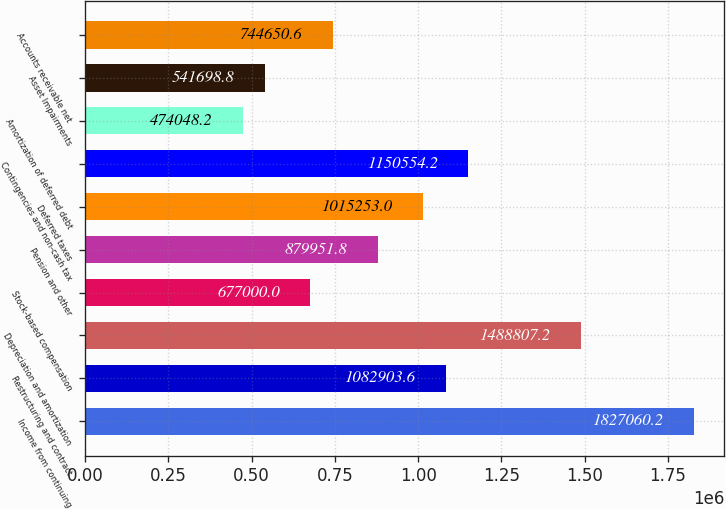Convert chart to OTSL. <chart><loc_0><loc_0><loc_500><loc_500><bar_chart><fcel>Income from continuing<fcel>Restructuring and contract<fcel>Depreciation and amortization<fcel>Stock-based compensation<fcel>Pension and other<fcel>Deferred taxes<fcel>Contingencies and non-cash tax<fcel>Amortization of deferred debt<fcel>Asset Impairments<fcel>Accounts receivable net<nl><fcel>1.82706e+06<fcel>1.0829e+06<fcel>1.48881e+06<fcel>677000<fcel>879952<fcel>1.01525e+06<fcel>1.15055e+06<fcel>474048<fcel>541699<fcel>744651<nl></chart> 